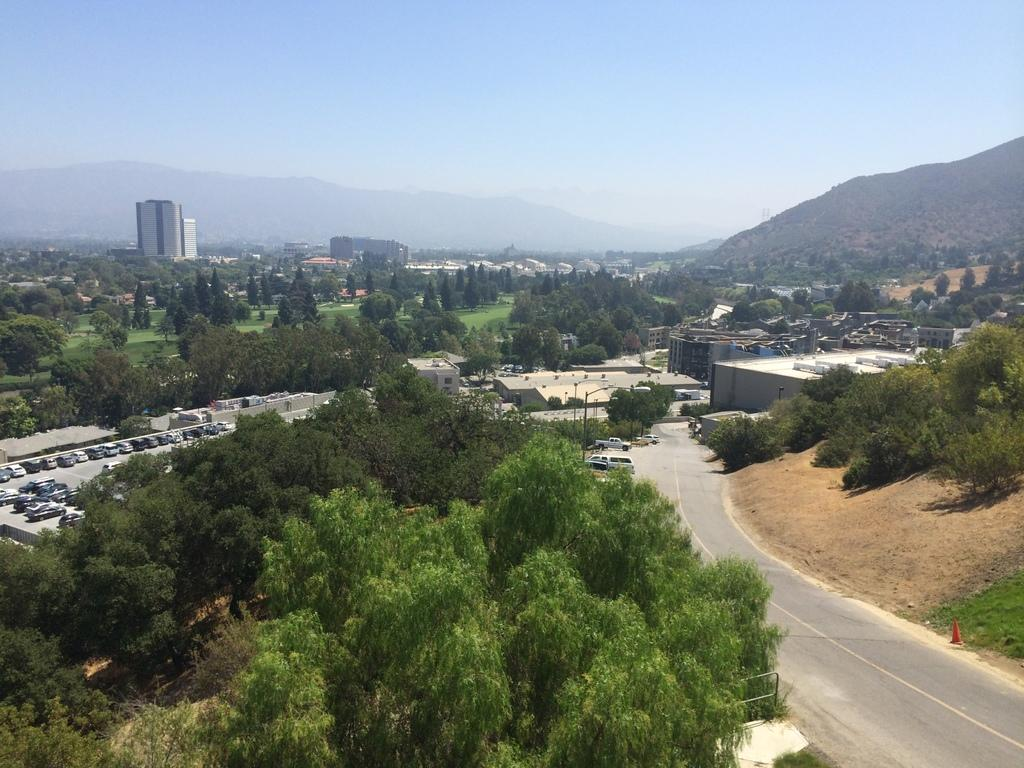What types of structures are present in the image? There are buildings and houses in the image. What natural elements can be seen in the image? There are trees and plants in the image. What man-made objects are visible on the road in the image? There are cars on the road in the image. What geographical feature is visible in the distance in the image? There are mountains visible in the image. What part of the natural environment is visible in the image? The sky is visible in the image. What is the purpose of the pump in the image? There is no pump present in the image. What action are the buildings performing in the image? Buildings do not perform actions; they are stationary structures. 